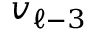Convert formula to latex. <formula><loc_0><loc_0><loc_500><loc_500>v _ { \ell - 3 }</formula> 